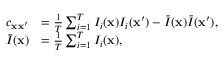Convert formula to latex. <formula><loc_0><loc_0><loc_500><loc_500>\begin{array} { r l } { c _ { { x x } ^ { \prime } } } & { = \frac { 1 } { T } \sum _ { i = 1 } ^ { T } I _ { i } ( { x } ) I _ { i } ( { x } ^ { \prime } ) - \bar { I } ( { x } ) \bar { I } ( { x } ^ { \prime } ) , } \\ { \bar { I } ( { x } ) } & { = \frac { 1 } { T } \sum _ { i = 1 } ^ { T } I _ { i } ( { x } ) , } \end{array}</formula> 